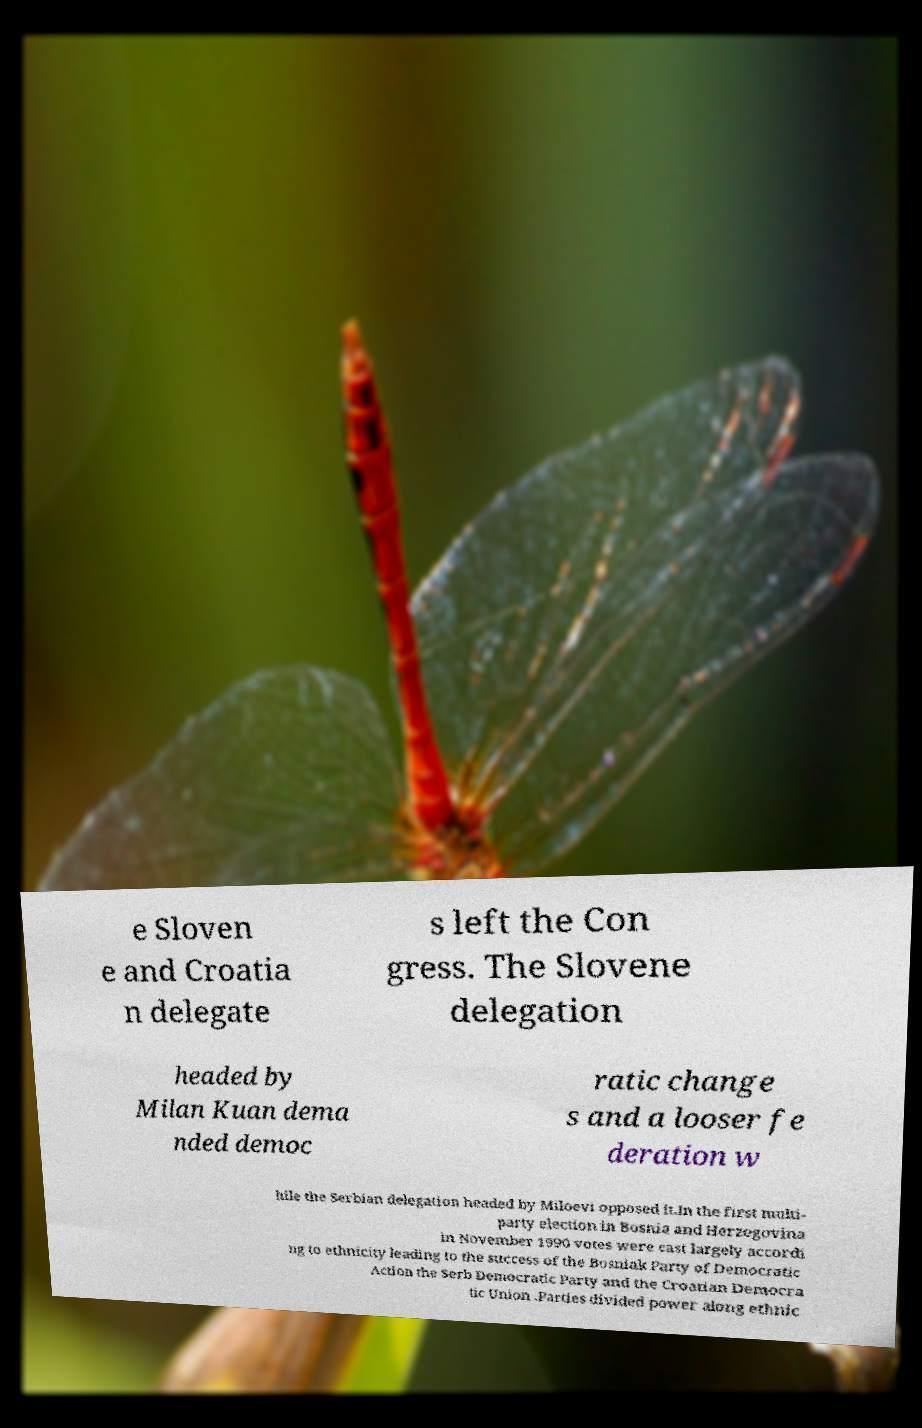I need the written content from this picture converted into text. Can you do that? e Sloven e and Croatia n delegate s left the Con gress. The Slovene delegation headed by Milan Kuan dema nded democ ratic change s and a looser fe deration w hile the Serbian delegation headed by Miloevi opposed it.In the first multi- party election in Bosnia and Herzegovina in November 1990 votes were cast largely accordi ng to ethnicity leading to the success of the Bosniak Party of Democratic Action the Serb Democratic Party and the Croatian Democra tic Union .Parties divided power along ethnic 